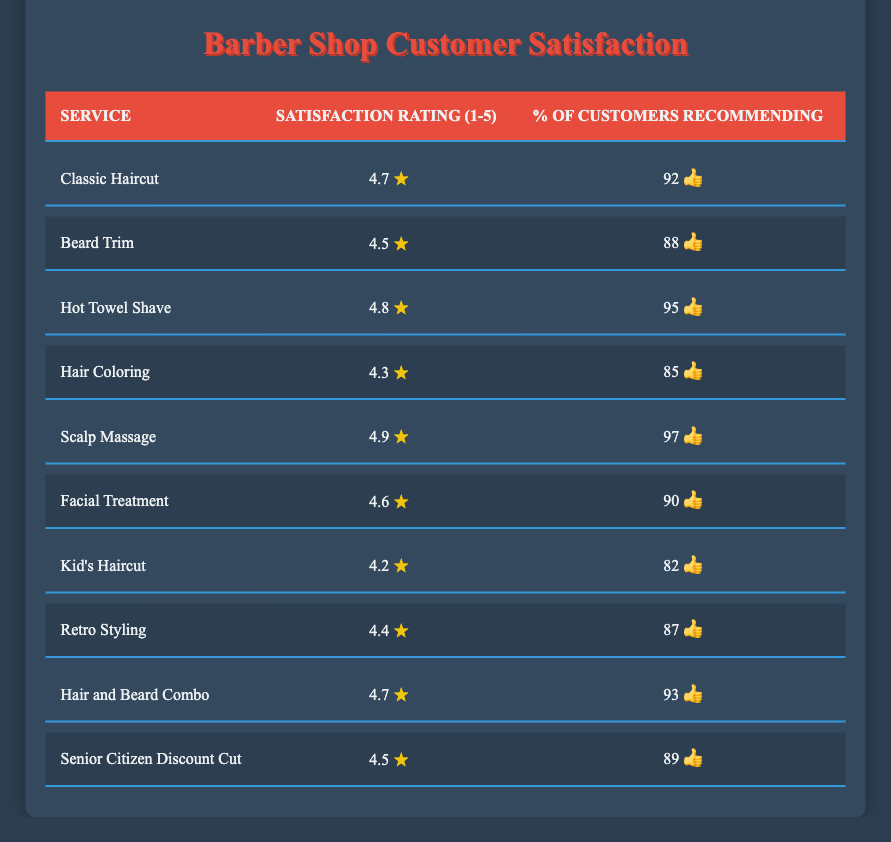What is the satisfaction rating for the Hot Towel Shave? The table lists the satisfaction ratings for different services. Looking at the row for "Hot Towel Shave," it shows a satisfaction rating of 4.8.
Answer: 4.8 Which service has the highest percentage of customers recommending it? By inspecting the "% of Customers Recommending" column, we see that "Scalp Massage" has the highest percentage, at 97%.
Answer: 97% What is the average satisfaction rating for all services combined? To find the average, we first add all the satisfaction ratings together: (4.7 + 4.5 + 4.8 + 4.3 + 4.9 + 4.6 + 4.2 + 4.4 + 4.7 + 4.5) = 46.6. There are 10 services, so we divide 46.6 by 10, resulting in an average of 4.66.
Answer: 4.66 Is the satisfaction rating for Kid's Haircut higher than that for Hair Coloring? Looking at the satisfaction ratings, "Kid's Haircut" has a rating of 4.2 while "Hair Coloring" has a rating of 4.3. Since 4.2 is less than 4.3, the answer is no.
Answer: No How many services have satisfaction ratings of 4.5 or higher? We check each satisfaction rating in the table: Classic Haircut (4.7), Beard Trim (4.5), Hot Towel Shave (4.8), Hair Coloring (4.3), Scalp Massage (4.9), Facial Treatment (4.6), Kid's Haircut (4.2), Retro Styling (4.4), Hair and Beard Combo (4.7), and Senior Citizen Discount Cut (4.5). Counting those that are 4.5 or higher, we have 8 services.
Answer: 8 